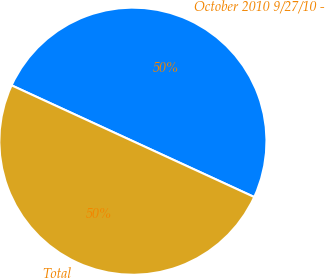Convert chart. <chart><loc_0><loc_0><loc_500><loc_500><pie_chart><fcel>October 2010 9/27/10 -<fcel>Total<nl><fcel>50.0%<fcel>50.0%<nl></chart> 